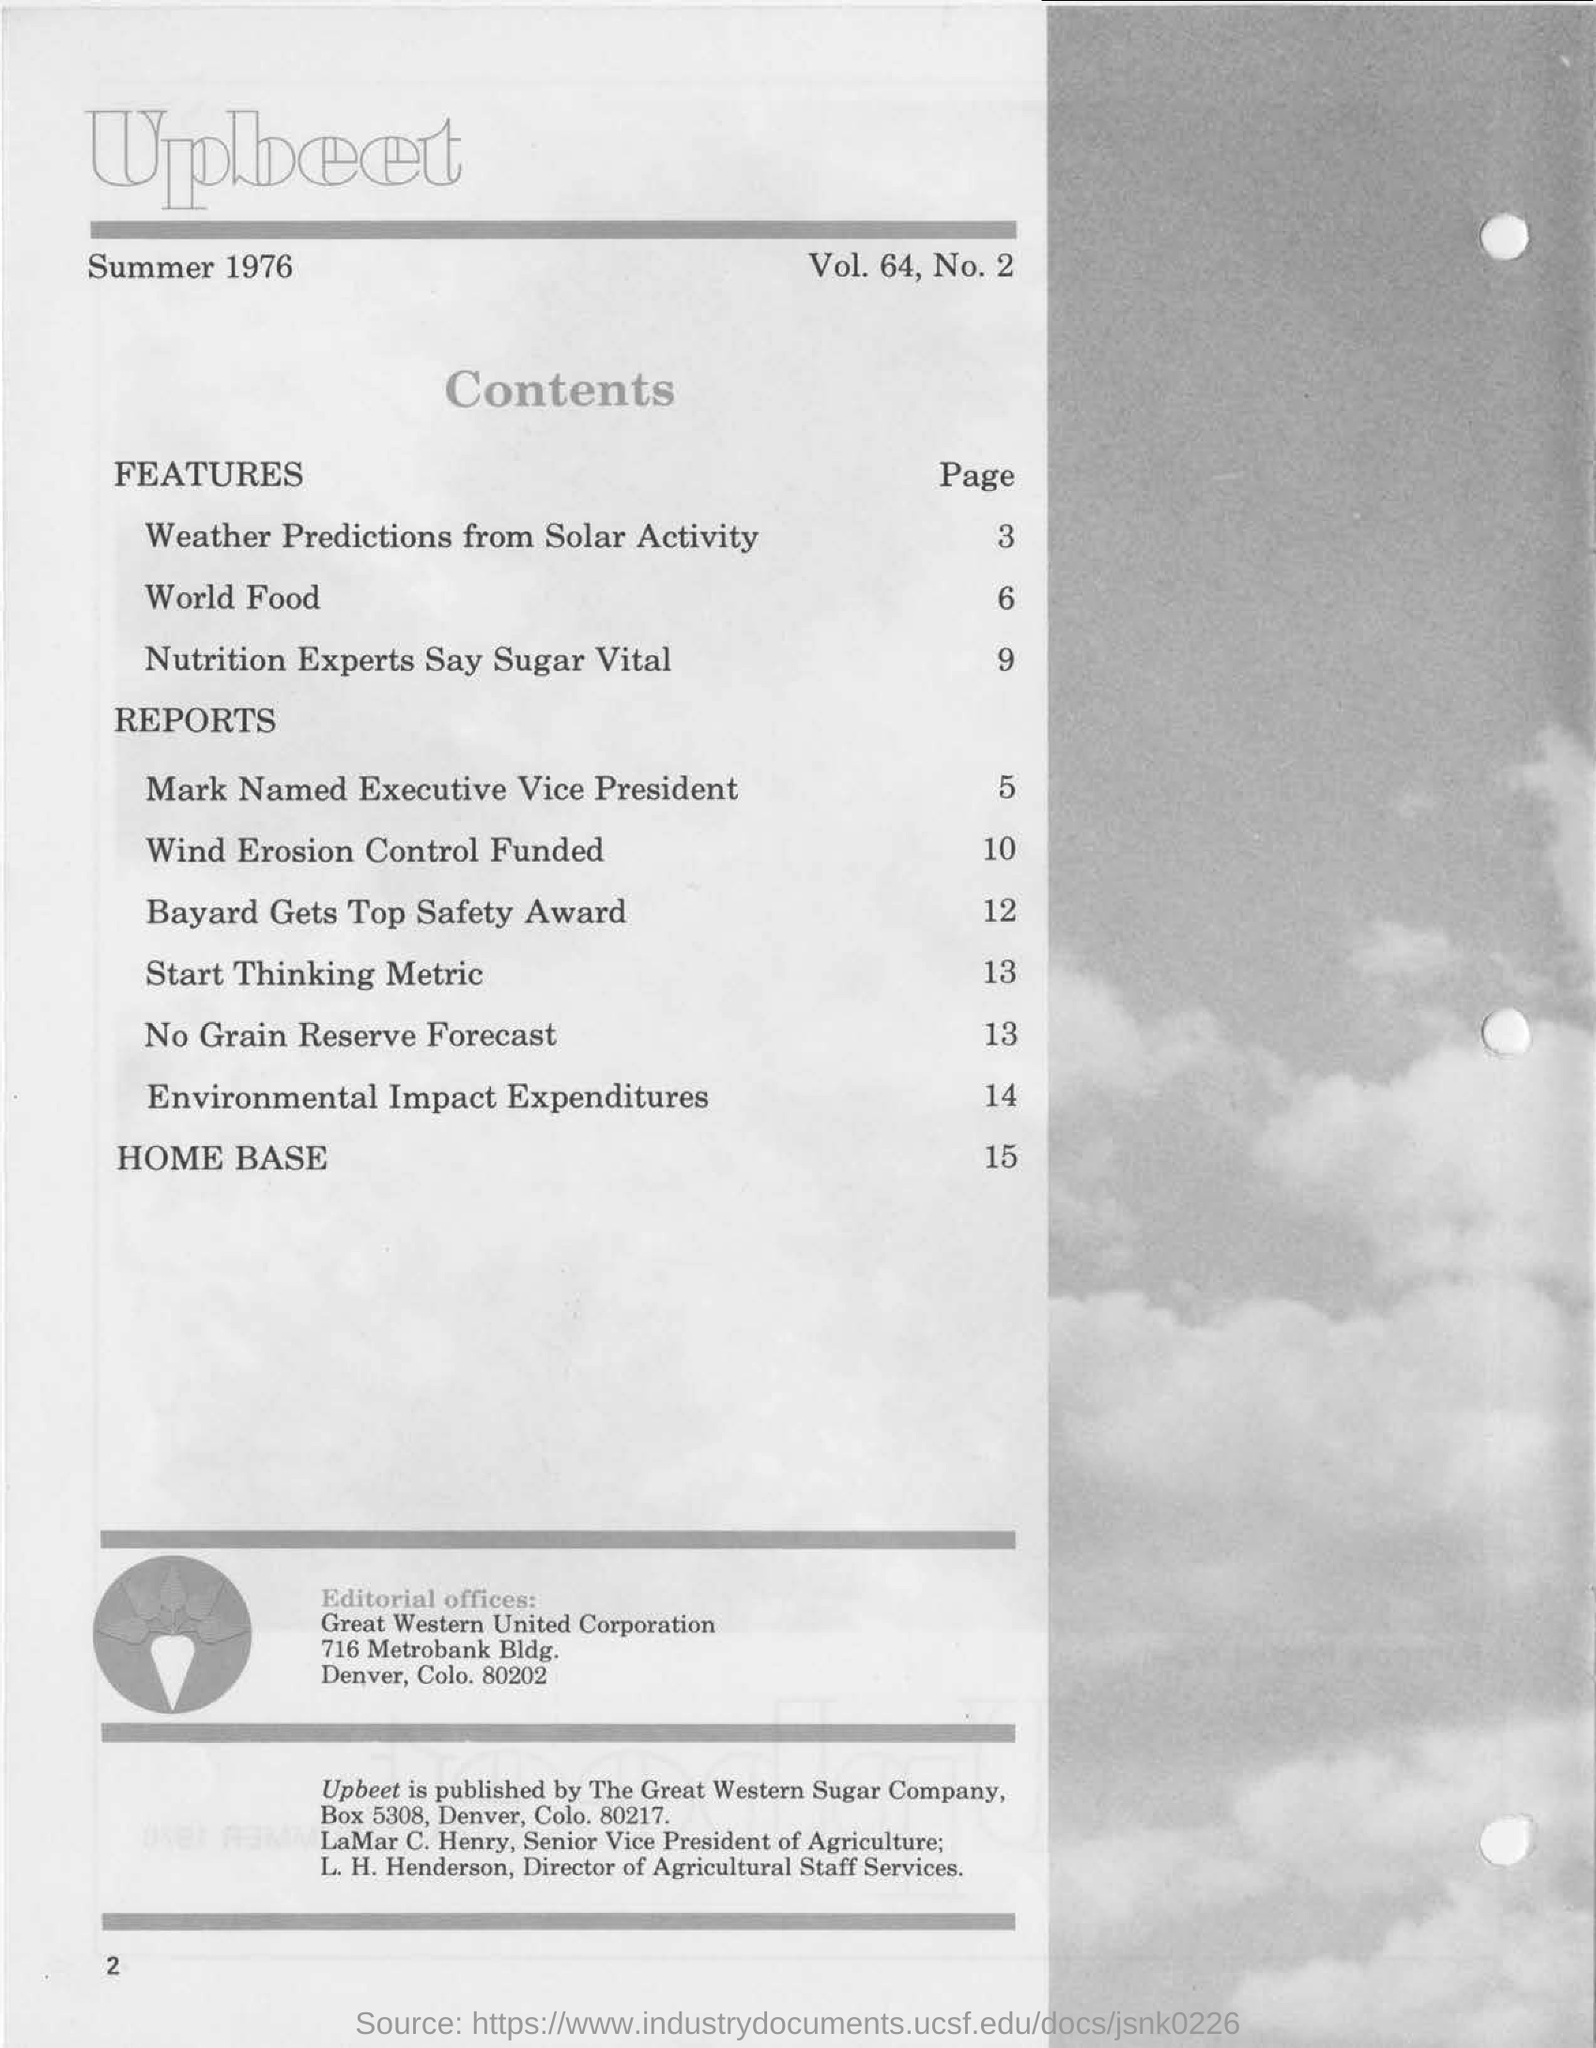Which "page" is weather predictions from solar activity on?
Your answer should be very brief. 3. Which "page" is world food on?
Offer a very short reply. 6. Which "page" is start thinking metric on?
Ensure brevity in your answer.  13. 